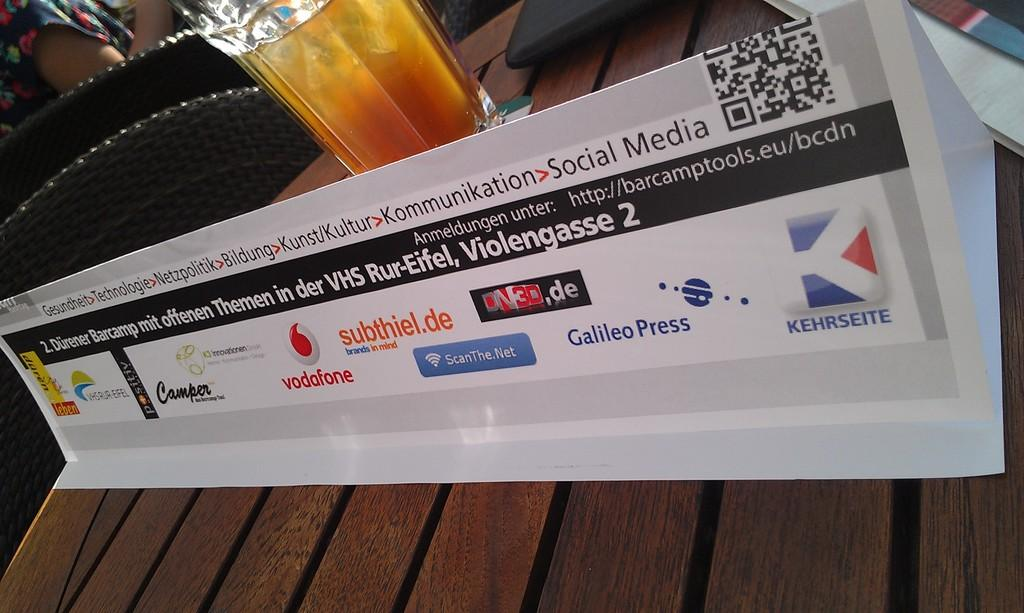<image>
Present a compact description of the photo's key features. a white advertisement that has Vodafone,camper and a few more on the bottom. 